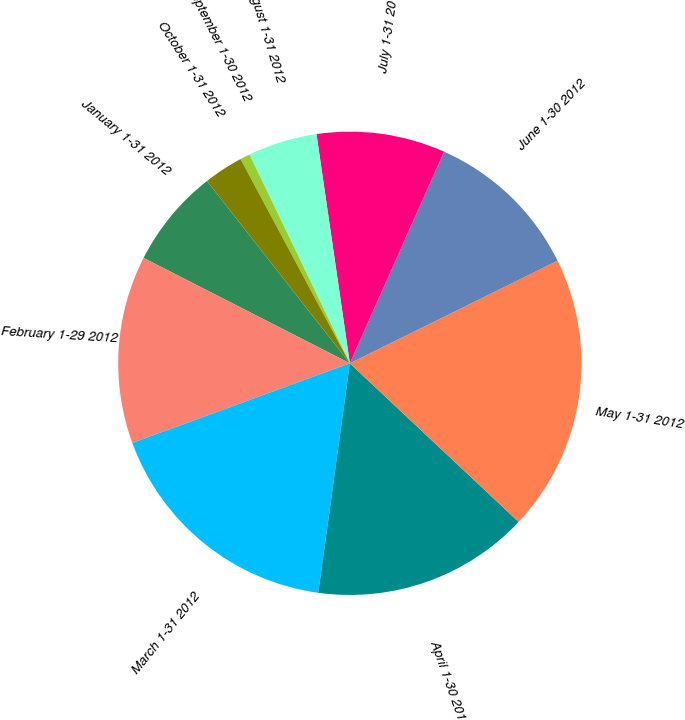<chart> <loc_0><loc_0><loc_500><loc_500><pie_chart><fcel>January 1-31 2012<fcel>February 1-29 2012<fcel>March 1-31 2012<fcel>April 1-30 2012<fcel>May 1-31 2012<fcel>June 1-30 2012<fcel>July 1-31 2012<fcel>August 1-31 2012<fcel>September 1-30 2012<fcel>October 1-31 2012<nl><fcel>6.9%<fcel>13.1%<fcel>17.24%<fcel>15.17%<fcel>19.31%<fcel>11.03%<fcel>8.97%<fcel>4.83%<fcel>0.69%<fcel>2.76%<nl></chart> 